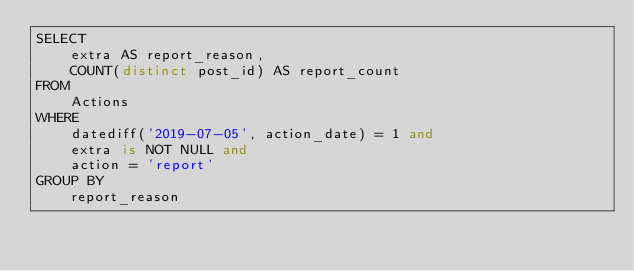<code> <loc_0><loc_0><loc_500><loc_500><_SQL_>SELECT 
    extra AS report_reason, 
    COUNT(distinct post_id) AS report_count
FROM 
    Actions
WHERE 
    datediff('2019-07-05', action_date) = 1 and 
    extra is NOT NULL and 
    action = 'report'
GROUP BY 
    report_reason</code> 